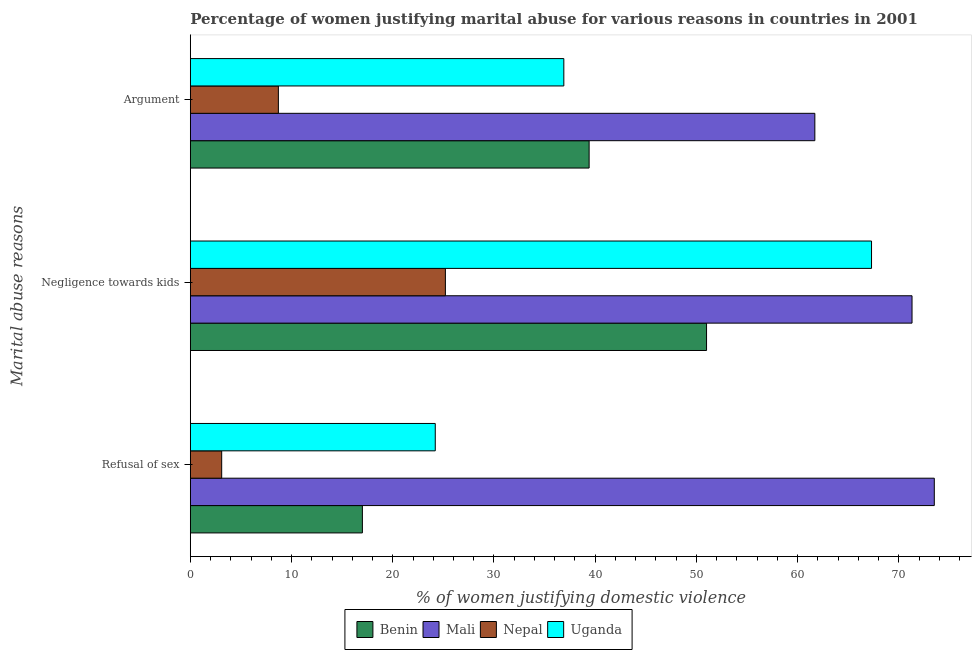Are the number of bars per tick equal to the number of legend labels?
Keep it short and to the point. Yes. How many bars are there on the 3rd tick from the bottom?
Keep it short and to the point. 4. What is the label of the 2nd group of bars from the top?
Offer a terse response. Negligence towards kids. What is the percentage of women justifying domestic violence due to arguments in Mali?
Provide a succinct answer. 61.7. Across all countries, what is the maximum percentage of women justifying domestic violence due to arguments?
Your answer should be very brief. 61.7. Across all countries, what is the minimum percentage of women justifying domestic violence due to refusal of sex?
Ensure brevity in your answer.  3.1. In which country was the percentage of women justifying domestic violence due to arguments maximum?
Your response must be concise. Mali. In which country was the percentage of women justifying domestic violence due to refusal of sex minimum?
Offer a very short reply. Nepal. What is the total percentage of women justifying domestic violence due to arguments in the graph?
Offer a very short reply. 146.7. What is the difference between the percentage of women justifying domestic violence due to arguments in Benin and that in Mali?
Give a very brief answer. -22.3. What is the difference between the percentage of women justifying domestic violence due to negligence towards kids in Benin and the percentage of women justifying domestic violence due to arguments in Uganda?
Provide a short and direct response. 14.1. What is the average percentage of women justifying domestic violence due to negligence towards kids per country?
Keep it short and to the point. 53.7. What is the difference between the percentage of women justifying domestic violence due to refusal of sex and percentage of women justifying domestic violence due to negligence towards kids in Mali?
Offer a very short reply. 2.2. What is the ratio of the percentage of women justifying domestic violence due to arguments in Uganda to that in Nepal?
Keep it short and to the point. 4.24. What is the difference between the highest and the second highest percentage of women justifying domestic violence due to negligence towards kids?
Your answer should be very brief. 4. In how many countries, is the percentage of women justifying domestic violence due to arguments greater than the average percentage of women justifying domestic violence due to arguments taken over all countries?
Keep it short and to the point. 3. Is the sum of the percentage of women justifying domestic violence due to refusal of sex in Benin and Uganda greater than the maximum percentage of women justifying domestic violence due to arguments across all countries?
Provide a succinct answer. No. What does the 1st bar from the top in Negligence towards kids represents?
Provide a short and direct response. Uganda. What does the 1st bar from the bottom in Argument represents?
Offer a terse response. Benin. Is it the case that in every country, the sum of the percentage of women justifying domestic violence due to refusal of sex and percentage of women justifying domestic violence due to negligence towards kids is greater than the percentage of women justifying domestic violence due to arguments?
Give a very brief answer. Yes. Are all the bars in the graph horizontal?
Your response must be concise. Yes. How many countries are there in the graph?
Your answer should be compact. 4. Does the graph contain grids?
Give a very brief answer. No. What is the title of the graph?
Offer a very short reply. Percentage of women justifying marital abuse for various reasons in countries in 2001. Does "Grenada" appear as one of the legend labels in the graph?
Provide a short and direct response. No. What is the label or title of the X-axis?
Offer a terse response. % of women justifying domestic violence. What is the label or title of the Y-axis?
Make the answer very short. Marital abuse reasons. What is the % of women justifying domestic violence in Benin in Refusal of sex?
Offer a very short reply. 17. What is the % of women justifying domestic violence of Mali in Refusal of sex?
Ensure brevity in your answer.  73.5. What is the % of women justifying domestic violence in Uganda in Refusal of sex?
Ensure brevity in your answer.  24.2. What is the % of women justifying domestic violence in Benin in Negligence towards kids?
Provide a succinct answer. 51. What is the % of women justifying domestic violence in Mali in Negligence towards kids?
Provide a succinct answer. 71.3. What is the % of women justifying domestic violence of Nepal in Negligence towards kids?
Offer a terse response. 25.2. What is the % of women justifying domestic violence in Uganda in Negligence towards kids?
Offer a terse response. 67.3. What is the % of women justifying domestic violence of Benin in Argument?
Provide a succinct answer. 39.4. What is the % of women justifying domestic violence of Mali in Argument?
Your answer should be compact. 61.7. What is the % of women justifying domestic violence of Uganda in Argument?
Provide a short and direct response. 36.9. Across all Marital abuse reasons, what is the maximum % of women justifying domestic violence of Mali?
Keep it short and to the point. 73.5. Across all Marital abuse reasons, what is the maximum % of women justifying domestic violence of Nepal?
Give a very brief answer. 25.2. Across all Marital abuse reasons, what is the maximum % of women justifying domestic violence of Uganda?
Ensure brevity in your answer.  67.3. Across all Marital abuse reasons, what is the minimum % of women justifying domestic violence in Mali?
Your answer should be very brief. 61.7. Across all Marital abuse reasons, what is the minimum % of women justifying domestic violence in Nepal?
Offer a very short reply. 3.1. Across all Marital abuse reasons, what is the minimum % of women justifying domestic violence in Uganda?
Your answer should be very brief. 24.2. What is the total % of women justifying domestic violence in Benin in the graph?
Make the answer very short. 107.4. What is the total % of women justifying domestic violence in Mali in the graph?
Ensure brevity in your answer.  206.5. What is the total % of women justifying domestic violence in Uganda in the graph?
Offer a very short reply. 128.4. What is the difference between the % of women justifying domestic violence in Benin in Refusal of sex and that in Negligence towards kids?
Your answer should be very brief. -34. What is the difference between the % of women justifying domestic violence of Mali in Refusal of sex and that in Negligence towards kids?
Offer a terse response. 2.2. What is the difference between the % of women justifying domestic violence of Nepal in Refusal of sex and that in Negligence towards kids?
Give a very brief answer. -22.1. What is the difference between the % of women justifying domestic violence in Uganda in Refusal of sex and that in Negligence towards kids?
Your answer should be very brief. -43.1. What is the difference between the % of women justifying domestic violence in Benin in Refusal of sex and that in Argument?
Your response must be concise. -22.4. What is the difference between the % of women justifying domestic violence of Mali in Refusal of sex and that in Argument?
Your response must be concise. 11.8. What is the difference between the % of women justifying domestic violence of Benin in Negligence towards kids and that in Argument?
Your response must be concise. 11.6. What is the difference between the % of women justifying domestic violence in Mali in Negligence towards kids and that in Argument?
Offer a terse response. 9.6. What is the difference between the % of women justifying domestic violence of Uganda in Negligence towards kids and that in Argument?
Ensure brevity in your answer.  30.4. What is the difference between the % of women justifying domestic violence of Benin in Refusal of sex and the % of women justifying domestic violence of Mali in Negligence towards kids?
Your answer should be compact. -54.3. What is the difference between the % of women justifying domestic violence of Benin in Refusal of sex and the % of women justifying domestic violence of Nepal in Negligence towards kids?
Ensure brevity in your answer.  -8.2. What is the difference between the % of women justifying domestic violence in Benin in Refusal of sex and the % of women justifying domestic violence in Uganda in Negligence towards kids?
Offer a terse response. -50.3. What is the difference between the % of women justifying domestic violence of Mali in Refusal of sex and the % of women justifying domestic violence of Nepal in Negligence towards kids?
Offer a terse response. 48.3. What is the difference between the % of women justifying domestic violence of Mali in Refusal of sex and the % of women justifying domestic violence of Uganda in Negligence towards kids?
Provide a short and direct response. 6.2. What is the difference between the % of women justifying domestic violence of Nepal in Refusal of sex and the % of women justifying domestic violence of Uganda in Negligence towards kids?
Your answer should be very brief. -64.2. What is the difference between the % of women justifying domestic violence of Benin in Refusal of sex and the % of women justifying domestic violence of Mali in Argument?
Your answer should be very brief. -44.7. What is the difference between the % of women justifying domestic violence of Benin in Refusal of sex and the % of women justifying domestic violence of Uganda in Argument?
Your answer should be very brief. -19.9. What is the difference between the % of women justifying domestic violence in Mali in Refusal of sex and the % of women justifying domestic violence in Nepal in Argument?
Ensure brevity in your answer.  64.8. What is the difference between the % of women justifying domestic violence of Mali in Refusal of sex and the % of women justifying domestic violence of Uganda in Argument?
Make the answer very short. 36.6. What is the difference between the % of women justifying domestic violence of Nepal in Refusal of sex and the % of women justifying domestic violence of Uganda in Argument?
Ensure brevity in your answer.  -33.8. What is the difference between the % of women justifying domestic violence of Benin in Negligence towards kids and the % of women justifying domestic violence of Mali in Argument?
Make the answer very short. -10.7. What is the difference between the % of women justifying domestic violence of Benin in Negligence towards kids and the % of women justifying domestic violence of Nepal in Argument?
Your response must be concise. 42.3. What is the difference between the % of women justifying domestic violence of Mali in Negligence towards kids and the % of women justifying domestic violence of Nepal in Argument?
Provide a short and direct response. 62.6. What is the difference between the % of women justifying domestic violence in Mali in Negligence towards kids and the % of women justifying domestic violence in Uganda in Argument?
Provide a succinct answer. 34.4. What is the difference between the % of women justifying domestic violence in Nepal in Negligence towards kids and the % of women justifying domestic violence in Uganda in Argument?
Your answer should be very brief. -11.7. What is the average % of women justifying domestic violence of Benin per Marital abuse reasons?
Ensure brevity in your answer.  35.8. What is the average % of women justifying domestic violence in Mali per Marital abuse reasons?
Keep it short and to the point. 68.83. What is the average % of women justifying domestic violence in Nepal per Marital abuse reasons?
Provide a succinct answer. 12.33. What is the average % of women justifying domestic violence of Uganda per Marital abuse reasons?
Your response must be concise. 42.8. What is the difference between the % of women justifying domestic violence of Benin and % of women justifying domestic violence of Mali in Refusal of sex?
Your answer should be compact. -56.5. What is the difference between the % of women justifying domestic violence in Benin and % of women justifying domestic violence in Nepal in Refusal of sex?
Provide a short and direct response. 13.9. What is the difference between the % of women justifying domestic violence in Mali and % of women justifying domestic violence in Nepal in Refusal of sex?
Make the answer very short. 70.4. What is the difference between the % of women justifying domestic violence of Mali and % of women justifying domestic violence of Uganda in Refusal of sex?
Provide a succinct answer. 49.3. What is the difference between the % of women justifying domestic violence of Nepal and % of women justifying domestic violence of Uganda in Refusal of sex?
Ensure brevity in your answer.  -21.1. What is the difference between the % of women justifying domestic violence in Benin and % of women justifying domestic violence in Mali in Negligence towards kids?
Your answer should be very brief. -20.3. What is the difference between the % of women justifying domestic violence in Benin and % of women justifying domestic violence in Nepal in Negligence towards kids?
Provide a short and direct response. 25.8. What is the difference between the % of women justifying domestic violence in Benin and % of women justifying domestic violence in Uganda in Negligence towards kids?
Your response must be concise. -16.3. What is the difference between the % of women justifying domestic violence of Mali and % of women justifying domestic violence of Nepal in Negligence towards kids?
Keep it short and to the point. 46.1. What is the difference between the % of women justifying domestic violence of Nepal and % of women justifying domestic violence of Uganda in Negligence towards kids?
Give a very brief answer. -42.1. What is the difference between the % of women justifying domestic violence in Benin and % of women justifying domestic violence in Mali in Argument?
Ensure brevity in your answer.  -22.3. What is the difference between the % of women justifying domestic violence in Benin and % of women justifying domestic violence in Nepal in Argument?
Your answer should be very brief. 30.7. What is the difference between the % of women justifying domestic violence in Benin and % of women justifying domestic violence in Uganda in Argument?
Make the answer very short. 2.5. What is the difference between the % of women justifying domestic violence of Mali and % of women justifying domestic violence of Nepal in Argument?
Provide a short and direct response. 53. What is the difference between the % of women justifying domestic violence of Mali and % of women justifying domestic violence of Uganda in Argument?
Provide a succinct answer. 24.8. What is the difference between the % of women justifying domestic violence of Nepal and % of women justifying domestic violence of Uganda in Argument?
Give a very brief answer. -28.2. What is the ratio of the % of women justifying domestic violence of Mali in Refusal of sex to that in Negligence towards kids?
Provide a succinct answer. 1.03. What is the ratio of the % of women justifying domestic violence of Nepal in Refusal of sex to that in Negligence towards kids?
Provide a succinct answer. 0.12. What is the ratio of the % of women justifying domestic violence of Uganda in Refusal of sex to that in Negligence towards kids?
Offer a very short reply. 0.36. What is the ratio of the % of women justifying domestic violence in Benin in Refusal of sex to that in Argument?
Give a very brief answer. 0.43. What is the ratio of the % of women justifying domestic violence in Mali in Refusal of sex to that in Argument?
Your response must be concise. 1.19. What is the ratio of the % of women justifying domestic violence of Nepal in Refusal of sex to that in Argument?
Give a very brief answer. 0.36. What is the ratio of the % of women justifying domestic violence in Uganda in Refusal of sex to that in Argument?
Provide a succinct answer. 0.66. What is the ratio of the % of women justifying domestic violence of Benin in Negligence towards kids to that in Argument?
Provide a succinct answer. 1.29. What is the ratio of the % of women justifying domestic violence in Mali in Negligence towards kids to that in Argument?
Your response must be concise. 1.16. What is the ratio of the % of women justifying domestic violence in Nepal in Negligence towards kids to that in Argument?
Your answer should be compact. 2.9. What is the ratio of the % of women justifying domestic violence in Uganda in Negligence towards kids to that in Argument?
Keep it short and to the point. 1.82. What is the difference between the highest and the second highest % of women justifying domestic violence in Benin?
Provide a short and direct response. 11.6. What is the difference between the highest and the second highest % of women justifying domestic violence of Mali?
Your answer should be very brief. 2.2. What is the difference between the highest and the second highest % of women justifying domestic violence in Uganda?
Provide a succinct answer. 30.4. What is the difference between the highest and the lowest % of women justifying domestic violence of Nepal?
Your answer should be compact. 22.1. What is the difference between the highest and the lowest % of women justifying domestic violence of Uganda?
Provide a succinct answer. 43.1. 